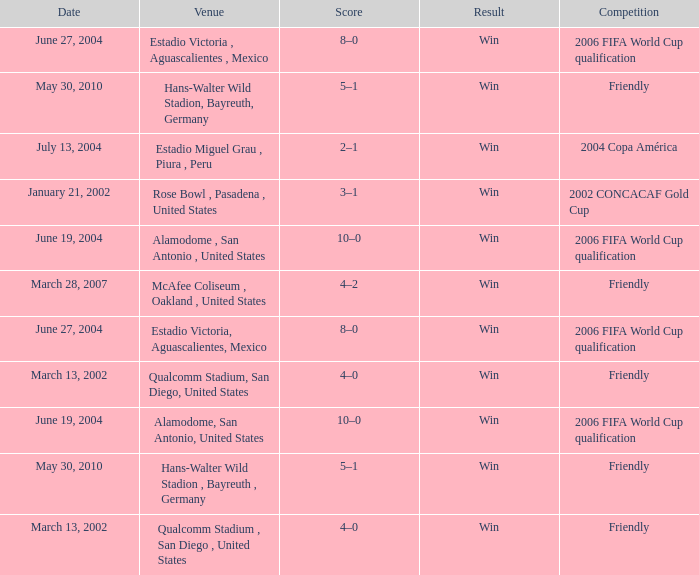What date has alamodome, san antonio, united states as the venue? June 19, 2004, June 19, 2004. 